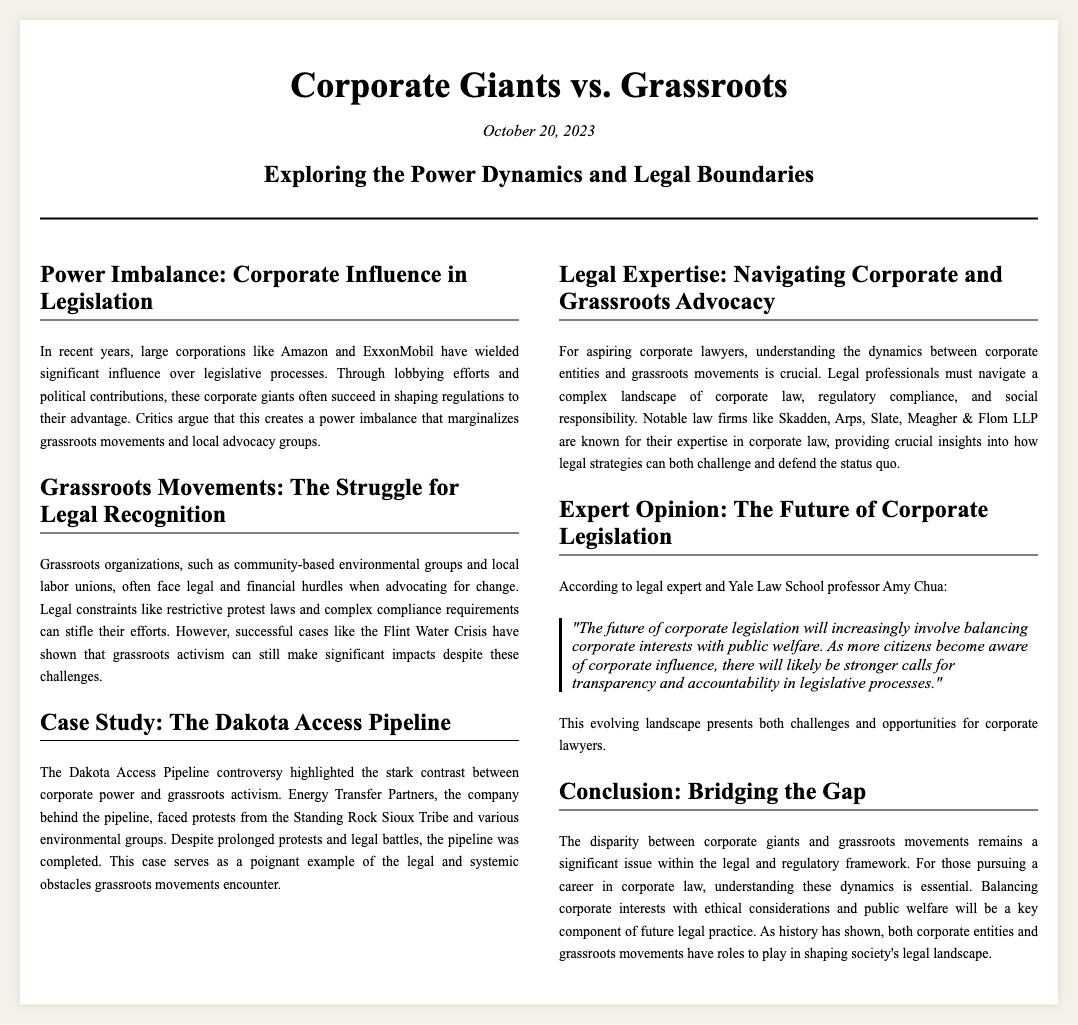What is the title of the article? The title appears at the top of the document and is prominently displayed as "Corporate Giants vs. Grassroots".
Answer: Corporate Giants vs. Grassroots When was the article published? The publication date is located below the title, indicating when the article was released.
Answer: October 20, 2023 What are some examples of corporate giants mentioned? The document lists specific corporations as examples of corporate giants influencing legislation.
Answer: Amazon and ExxonMobil What legal constraints do grassroots organizations face? The section discusses various challenges that hinder grassroots groups in their advocacy efforts.
Answer: Restrictive protest laws and complex compliance requirements Who provided expert opinion in the article? The article quotes an expert, emphasizing their credentials in relation to the topics discussed.
Answer: Amy Chua What case study is highlighted to contrast corporate power and grassroots activism? The article specifies a significant case that illustrates the struggle between corporate interests and grassroots resistance.
Answer: The Dakota Access Pipeline What fundamental issue does the conclusion address? The conclusion sums up the main theme regarding the disparity that exists between the two forces discussed.
Answer: Disparity between corporate giants and grassroots movements What is a key aspect for aspiring corporate lawyers to understand? The article advises on vital knowledge areas that will benefit those looking to enter corporate law.
Answer: Dynamics between corporate entities and grassroots movements What do grassroots organizations aim to achieve despite hurdles? The text highlights the ultimate goal of grassroots movements even in the face of legal obstacles.
Answer: Significant impacts 